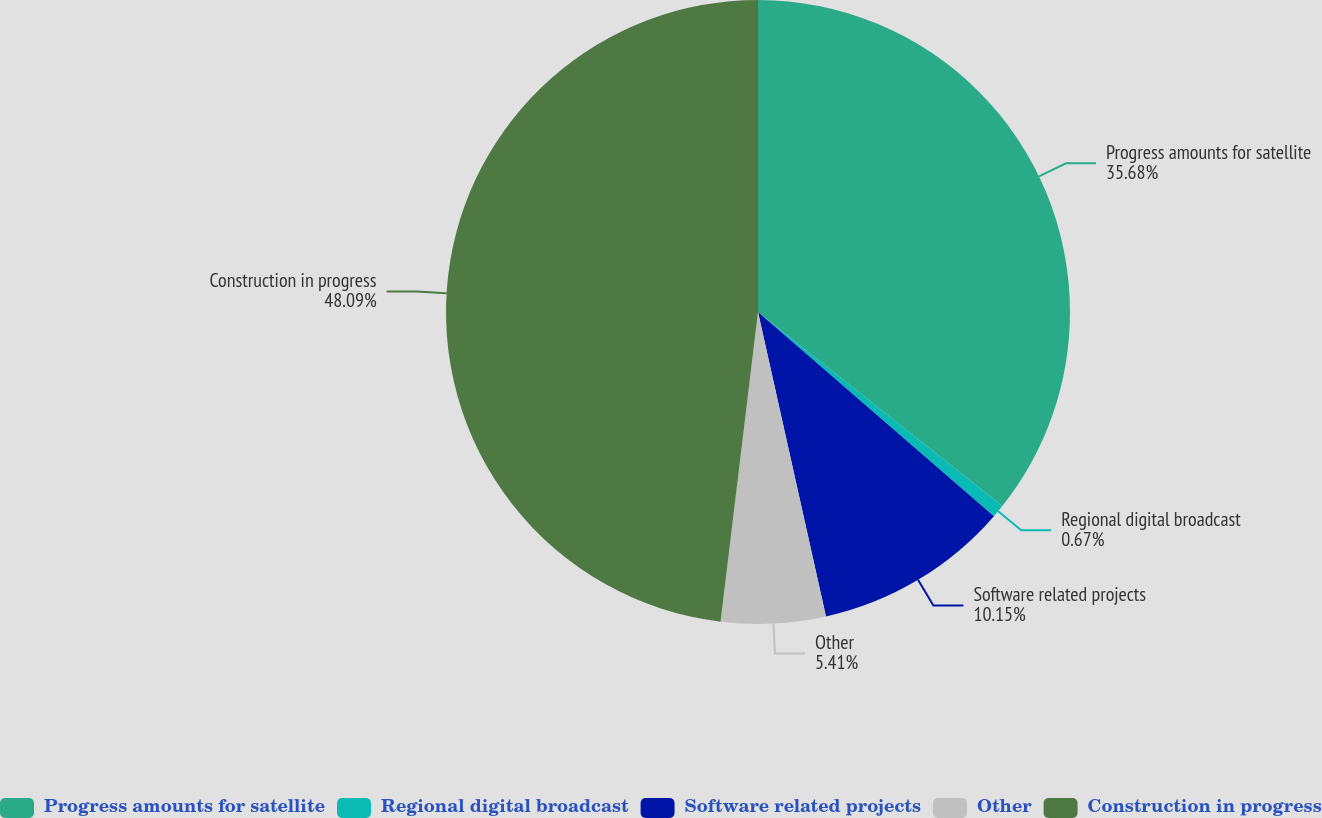Convert chart to OTSL. <chart><loc_0><loc_0><loc_500><loc_500><pie_chart><fcel>Progress amounts for satellite<fcel>Regional digital broadcast<fcel>Software related projects<fcel>Other<fcel>Construction in progress<nl><fcel>35.68%<fcel>0.67%<fcel>10.15%<fcel>5.41%<fcel>48.08%<nl></chart> 